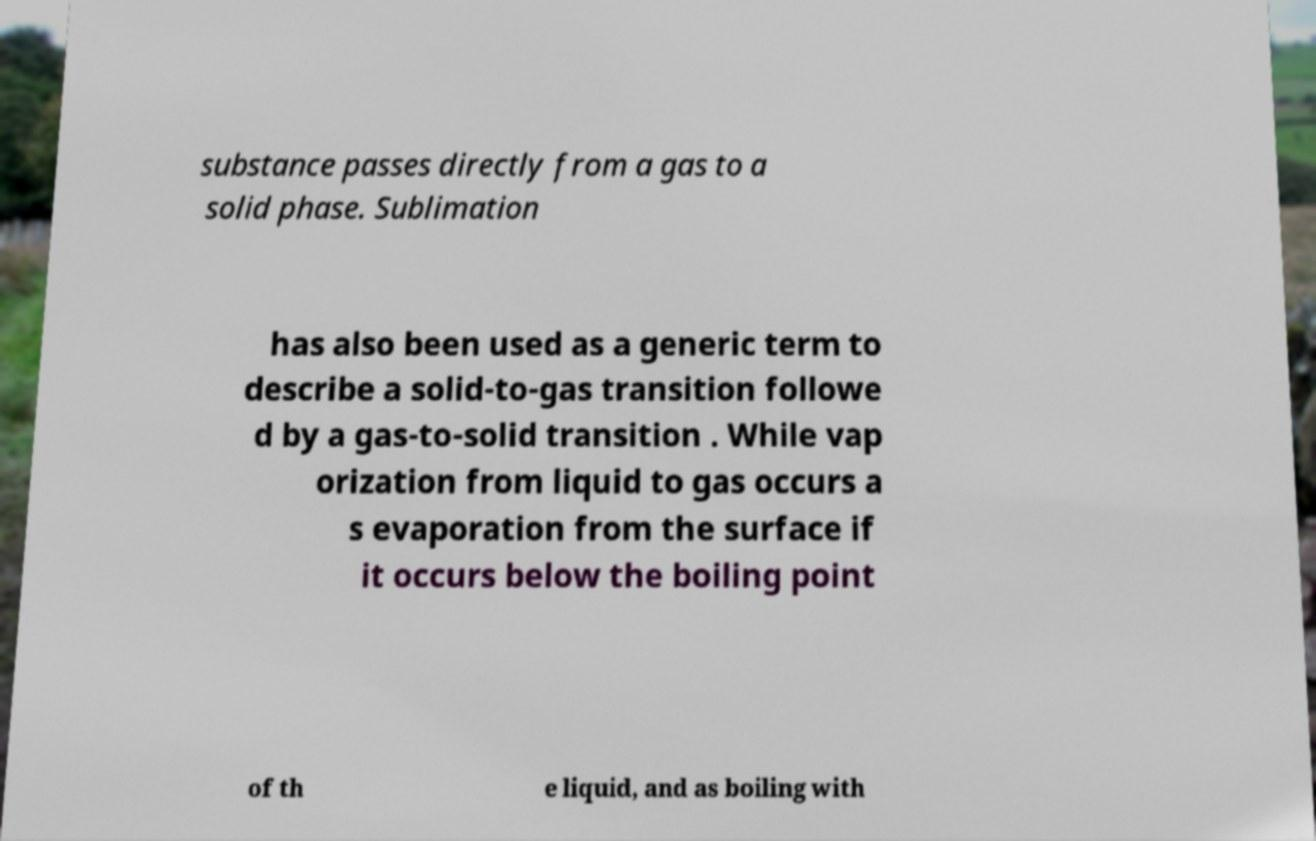Can you accurately transcribe the text from the provided image for me? substance passes directly from a gas to a solid phase. Sublimation has also been used as a generic term to describe a solid-to-gas transition followe d by a gas-to-solid transition . While vap orization from liquid to gas occurs a s evaporation from the surface if it occurs below the boiling point of th e liquid, and as boiling with 